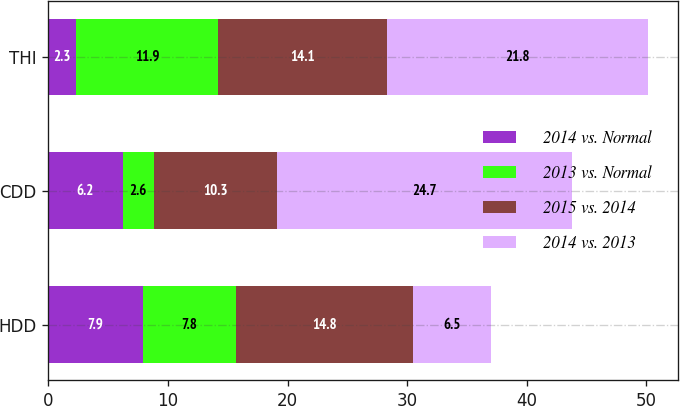<chart> <loc_0><loc_0><loc_500><loc_500><stacked_bar_chart><ecel><fcel>HDD<fcel>CDD<fcel>THI<nl><fcel>2014 vs. Normal<fcel>7.9<fcel>6.2<fcel>2.3<nl><fcel>2013 vs. Normal<fcel>7.8<fcel>2.6<fcel>11.9<nl><fcel>2015 vs. 2014<fcel>14.8<fcel>10.3<fcel>14.1<nl><fcel>2014 vs. 2013<fcel>6.5<fcel>24.7<fcel>21.8<nl></chart> 